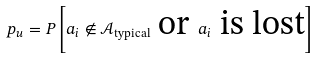Convert formula to latex. <formula><loc_0><loc_0><loc_500><loc_500>p _ { u } = P \left [ a _ { i } \notin \mathcal { A } _ { \text {typical} } \text { or } a _ { i } \text { is lost} \right ]</formula> 